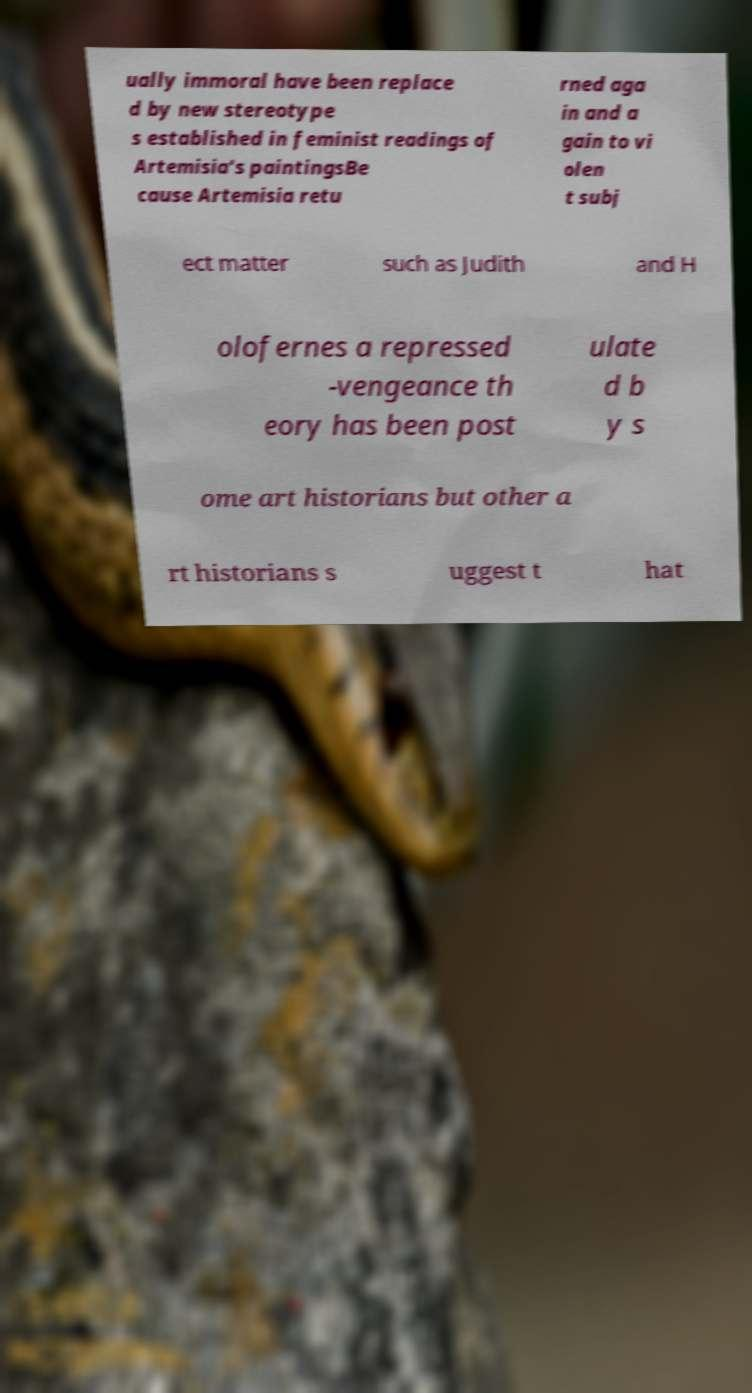What messages or text are displayed in this image? I need them in a readable, typed format. ually immoral have been replace d by new stereotype s established in feminist readings of Artemisia's paintingsBe cause Artemisia retu rned aga in and a gain to vi olen t subj ect matter such as Judith and H olofernes a repressed -vengeance th eory has been post ulate d b y s ome art historians but other a rt historians s uggest t hat 